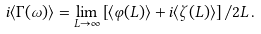<formula> <loc_0><loc_0><loc_500><loc_500>i \langle \Gamma ( \omega ) \rangle = \lim _ { L \to \infty } \left [ \langle \varphi ( L ) \rangle + i \langle \zeta ( L ) \rangle \right ] / 2 L \, .</formula> 